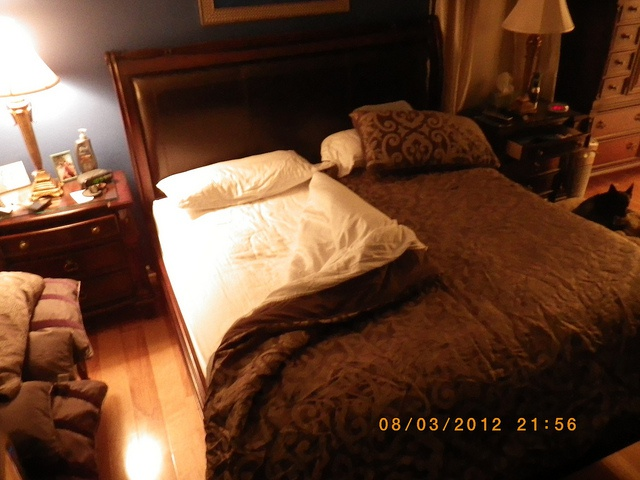Describe the objects in this image and their specific colors. I can see bed in white, black, maroon, ivory, and tan tones and dog in white, black, maroon, and brown tones in this image. 